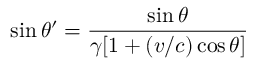Convert formula to latex. <formula><loc_0><loc_0><loc_500><loc_500>\sin \theta ^ { \prime } = { \frac { \sin \theta } { \gamma [ 1 + ( v / c ) \cos \theta ] } }</formula> 